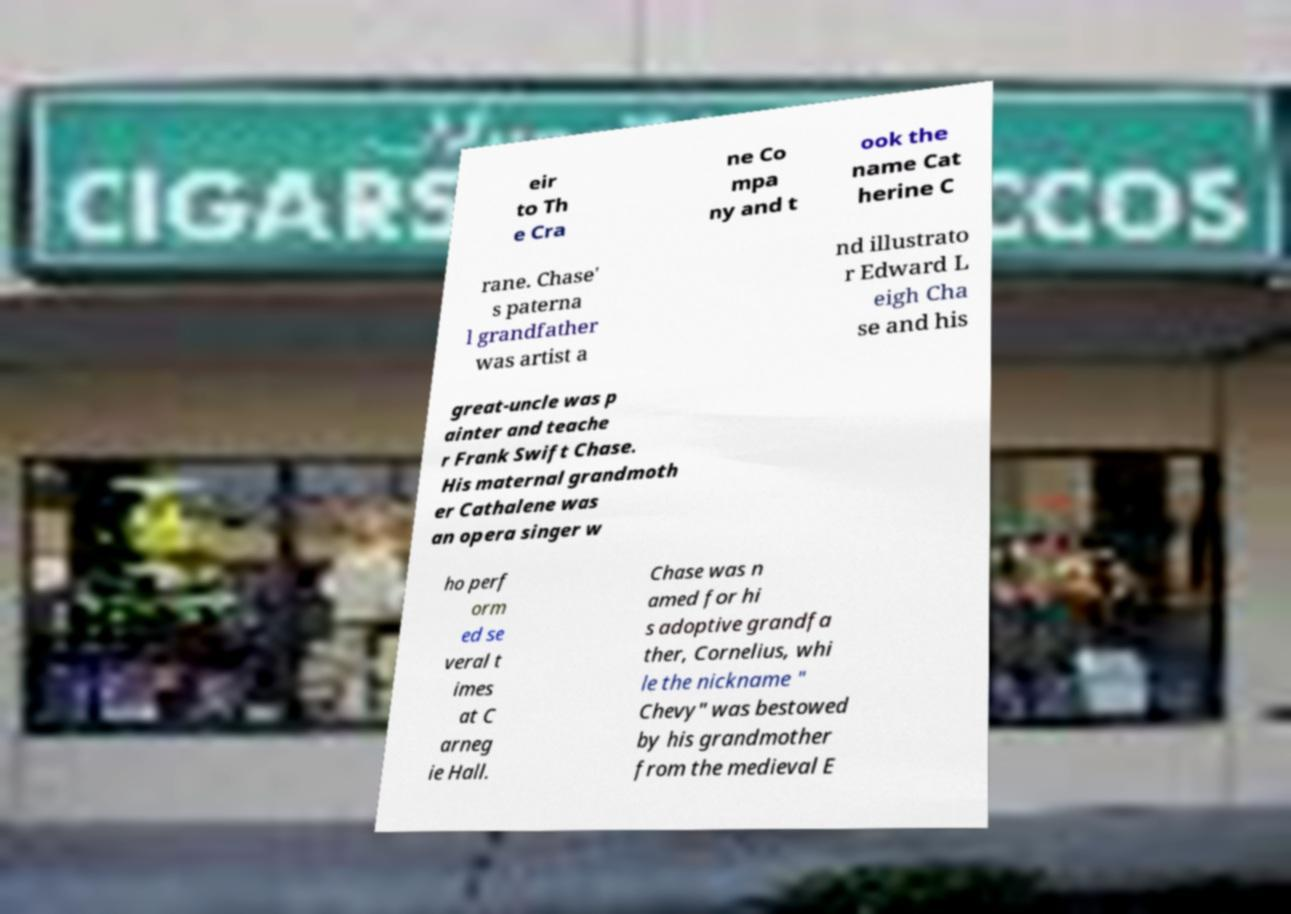There's text embedded in this image that I need extracted. Can you transcribe it verbatim? eir to Th e Cra ne Co mpa ny and t ook the name Cat herine C rane. Chase' s paterna l grandfather was artist a nd illustrato r Edward L eigh Cha se and his great-uncle was p ainter and teache r Frank Swift Chase. His maternal grandmoth er Cathalene was an opera singer w ho perf orm ed se veral t imes at C arneg ie Hall. Chase was n amed for hi s adoptive grandfa ther, Cornelius, whi le the nickname " Chevy" was bestowed by his grandmother from the medieval E 